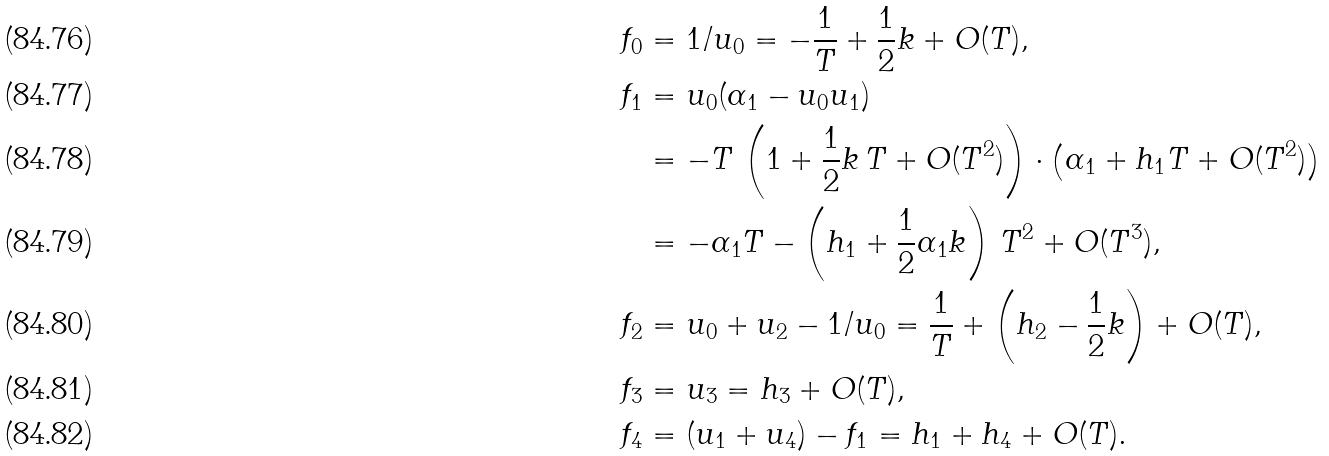<formula> <loc_0><loc_0><loc_500><loc_500>f _ { 0 } & = 1 / u _ { 0 } = - \frac { 1 } { T } + \frac { 1 } { 2 } k + O ( T ) , \\ f _ { 1 } & = u _ { 0 } ( \alpha _ { 1 } - u _ { 0 } u _ { 1 } ) \\ & = - T \, \left ( 1 + \frac { 1 } { 2 } k \, T + O ( T ^ { 2 } ) \right ) \cdot \left ( \alpha _ { 1 } + h _ { 1 } T + O ( T ^ { 2 } ) \right ) \\ & = - \alpha _ { 1 } T - \left ( h _ { 1 } + \frac { 1 } { 2 } \alpha _ { 1 } k \right ) \, T ^ { 2 } + O ( T ^ { 3 } ) , \\ f _ { 2 } & = u _ { 0 } + u _ { 2 } - 1 / u _ { 0 } = \frac { 1 } { T } + \left ( h _ { 2 } - \frac { 1 } { 2 } k \right ) + O ( T ) , \\ f _ { 3 } & = u _ { 3 } = h _ { 3 } + O ( T ) , \\ f _ { 4 } & = ( u _ { 1 } + u _ { 4 } ) - f _ { 1 } = h _ { 1 } + h _ { 4 } + O ( T ) .</formula> 